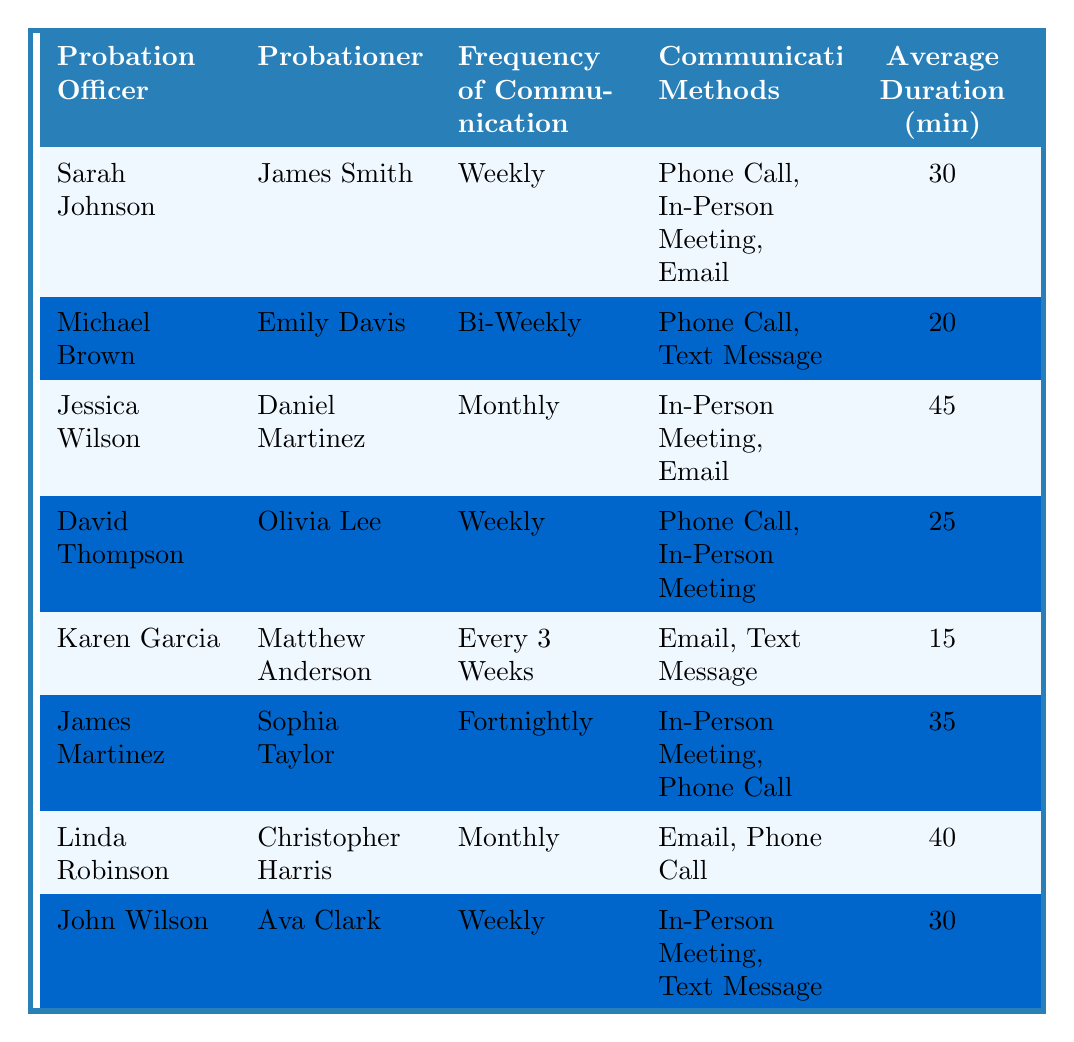What is the frequency of communication between Sarah Johnson and James Smith? The table lists the frequency of communication under the column "Frequency of Communication" for Sarah Johnson and James Smith, which is stated as "Weekly."
Answer: Weekly Which probationer has the longest average communication duration? By examining the "Average Duration (min)" column, Jessica Wilson and Daniel Martinez have the highest value of 45 minutes, making it the longest duration.
Answer: Daniel Martinez Are there any probationers who communicate with their probation officers monthly? Checking the "Frequency of Communication" column, we see Jessica Wilson & Daniel Martinez and Linda Robinson & Christopher Harris communicate monthly. Thus, the answer is yes.
Answer: Yes What are the communication methods used by David Thompson for Olivia Lee? The communication methods for Olivia Lee under David Thompson are provided in the "Communication Methods" column and include "Phone Call" and "In-Person Meeting."
Answer: Phone Call, In-Person Meeting How many probationers have weekly communication with their officers? Looking at the "Frequency of Communication" column, we see that James Smith, Olivia Lee, and Ava Clark have weekly communication, totaling three probationers.
Answer: Three What is the average duration of communication for Karen Garcia with Matthew Anderson? The table indicates that the average duration of communication for Karen Garcia with Matthew Anderson is 15 minutes as per the "Average Duration (min)" column.
Answer: 15 minutes If you combine the frequencies of Michael Brown's and Jessica Wilson's communication, how often do they communicate in terms of weeks? Michael Brown communicates bi-weekly (every two weeks) and Jessica Wilson communicates monthly (every four weeks). Adding these, on average, they communicate every three weeks.
Answer: Every three weeks Is the average communication duration longer for probationers who meet weekly or those who meet monthly? Probationers who meet weekly (30, 25, and 30 minutes, respectively) have an average duration of approximately 28.33 minutes. Probationers who meet monthly (45 and 40 minutes) have an average of 42.5 minutes. Hence, monthly communication is longer.
Answer: Monthly communication is longer Which communication method is most frequently used among all probation officers? Analyzing the "Communication Methods" for all entries, 'Phone Call' appears the most frequently across different probation officers.
Answer: Phone Call What is the average duration per communication for all probationers under weekly communication? Adding up the average durations for weekly communications (30 for James Smith, 25 for Olivia Lee, and 30 for Ava Clark) gives 85 minutes. With three probationers, the average is 85/3 = approximately 28.33 minutes.
Answer: 28.33 minutes 